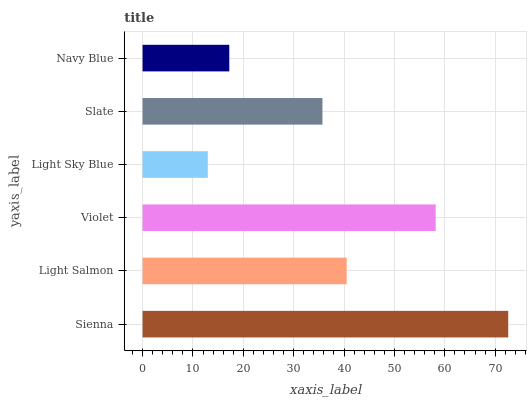Is Light Sky Blue the minimum?
Answer yes or no. Yes. Is Sienna the maximum?
Answer yes or no. Yes. Is Light Salmon the minimum?
Answer yes or no. No. Is Light Salmon the maximum?
Answer yes or no. No. Is Sienna greater than Light Salmon?
Answer yes or no. Yes. Is Light Salmon less than Sienna?
Answer yes or no. Yes. Is Light Salmon greater than Sienna?
Answer yes or no. No. Is Sienna less than Light Salmon?
Answer yes or no. No. Is Light Salmon the high median?
Answer yes or no. Yes. Is Slate the low median?
Answer yes or no. Yes. Is Sienna the high median?
Answer yes or no. No. Is Light Sky Blue the low median?
Answer yes or no. No. 